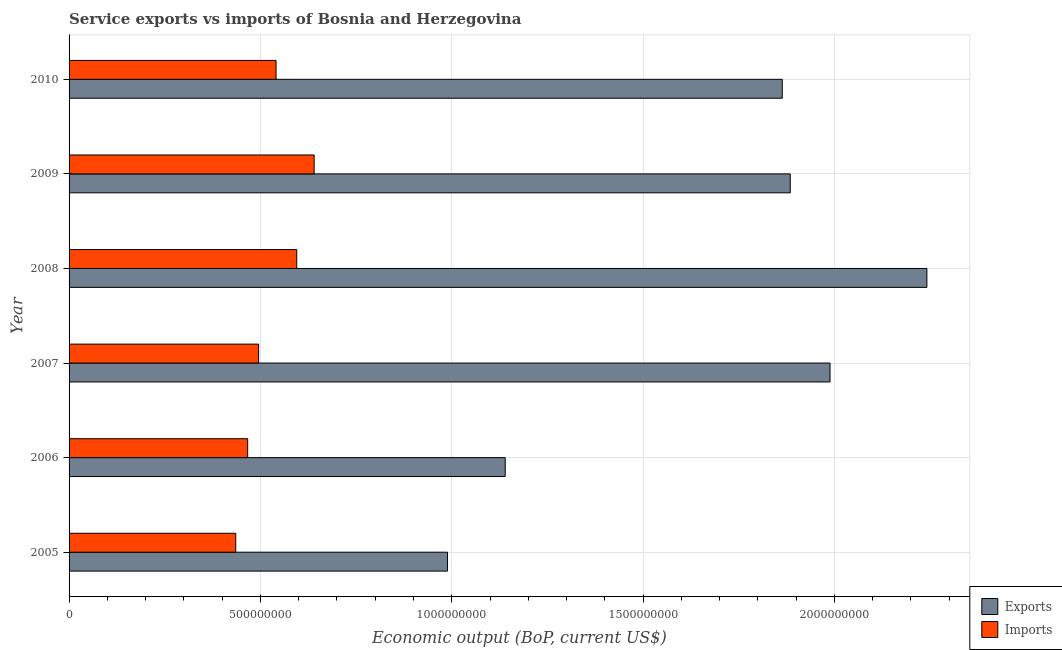How many groups of bars are there?
Offer a very short reply. 6. Are the number of bars on each tick of the Y-axis equal?
Provide a succinct answer. Yes. In how many cases, is the number of bars for a given year not equal to the number of legend labels?
Offer a terse response. 0. What is the amount of service exports in 2006?
Keep it short and to the point. 1.14e+09. Across all years, what is the maximum amount of service imports?
Provide a succinct answer. 6.40e+08. Across all years, what is the minimum amount of service imports?
Your answer should be compact. 4.36e+08. In which year was the amount of service imports minimum?
Provide a short and direct response. 2005. What is the total amount of service exports in the graph?
Offer a very short reply. 1.01e+1. What is the difference between the amount of service imports in 2006 and that in 2008?
Give a very brief answer. -1.28e+08. What is the difference between the amount of service exports in 2009 and the amount of service imports in 2010?
Your answer should be very brief. 1.34e+09. What is the average amount of service exports per year?
Your answer should be very brief. 1.68e+09. In the year 2009, what is the difference between the amount of service exports and amount of service imports?
Offer a terse response. 1.24e+09. In how many years, is the amount of service imports greater than 1000000000 US$?
Your answer should be compact. 0. What is the ratio of the amount of service imports in 2009 to that in 2010?
Your answer should be very brief. 1.18. What is the difference between the highest and the second highest amount of service exports?
Your answer should be compact. 2.53e+08. What is the difference between the highest and the lowest amount of service exports?
Provide a succinct answer. 1.25e+09. In how many years, is the amount of service imports greater than the average amount of service imports taken over all years?
Make the answer very short. 3. Is the sum of the amount of service exports in 2006 and 2010 greater than the maximum amount of service imports across all years?
Your answer should be very brief. Yes. What does the 1st bar from the top in 2006 represents?
Provide a short and direct response. Imports. What does the 2nd bar from the bottom in 2008 represents?
Ensure brevity in your answer.  Imports. Are all the bars in the graph horizontal?
Your answer should be very brief. Yes. How many years are there in the graph?
Give a very brief answer. 6. What is the difference between two consecutive major ticks on the X-axis?
Your answer should be compact. 5.00e+08. Are the values on the major ticks of X-axis written in scientific E-notation?
Ensure brevity in your answer.  No. Where does the legend appear in the graph?
Give a very brief answer. Bottom right. What is the title of the graph?
Give a very brief answer. Service exports vs imports of Bosnia and Herzegovina. What is the label or title of the X-axis?
Your response must be concise. Economic output (BoP, current US$). What is the label or title of the Y-axis?
Your response must be concise. Year. What is the Economic output (BoP, current US$) of Exports in 2005?
Your response must be concise. 9.89e+08. What is the Economic output (BoP, current US$) of Imports in 2005?
Keep it short and to the point. 4.36e+08. What is the Economic output (BoP, current US$) of Exports in 2006?
Your answer should be very brief. 1.14e+09. What is the Economic output (BoP, current US$) of Imports in 2006?
Your response must be concise. 4.67e+08. What is the Economic output (BoP, current US$) in Exports in 2007?
Your answer should be very brief. 1.99e+09. What is the Economic output (BoP, current US$) of Imports in 2007?
Offer a terse response. 4.95e+08. What is the Economic output (BoP, current US$) in Exports in 2008?
Make the answer very short. 2.24e+09. What is the Economic output (BoP, current US$) in Imports in 2008?
Make the answer very short. 5.95e+08. What is the Economic output (BoP, current US$) of Exports in 2009?
Keep it short and to the point. 1.88e+09. What is the Economic output (BoP, current US$) of Imports in 2009?
Give a very brief answer. 6.40e+08. What is the Economic output (BoP, current US$) of Exports in 2010?
Make the answer very short. 1.86e+09. What is the Economic output (BoP, current US$) of Imports in 2010?
Your answer should be compact. 5.41e+08. Across all years, what is the maximum Economic output (BoP, current US$) of Exports?
Your response must be concise. 2.24e+09. Across all years, what is the maximum Economic output (BoP, current US$) of Imports?
Keep it short and to the point. 6.40e+08. Across all years, what is the minimum Economic output (BoP, current US$) of Exports?
Your response must be concise. 9.89e+08. Across all years, what is the minimum Economic output (BoP, current US$) of Imports?
Your answer should be compact. 4.36e+08. What is the total Economic output (BoP, current US$) in Exports in the graph?
Your response must be concise. 1.01e+1. What is the total Economic output (BoP, current US$) of Imports in the graph?
Your response must be concise. 3.17e+09. What is the difference between the Economic output (BoP, current US$) in Exports in 2005 and that in 2006?
Give a very brief answer. -1.51e+08. What is the difference between the Economic output (BoP, current US$) of Imports in 2005 and that in 2006?
Your answer should be very brief. -3.12e+07. What is the difference between the Economic output (BoP, current US$) of Exports in 2005 and that in 2007?
Your answer should be compact. -1.00e+09. What is the difference between the Economic output (BoP, current US$) in Imports in 2005 and that in 2007?
Ensure brevity in your answer.  -5.97e+07. What is the difference between the Economic output (BoP, current US$) in Exports in 2005 and that in 2008?
Offer a terse response. -1.25e+09. What is the difference between the Economic output (BoP, current US$) in Imports in 2005 and that in 2008?
Offer a very short reply. -1.59e+08. What is the difference between the Economic output (BoP, current US$) of Exports in 2005 and that in 2009?
Offer a terse response. -8.96e+08. What is the difference between the Economic output (BoP, current US$) of Imports in 2005 and that in 2009?
Offer a terse response. -2.05e+08. What is the difference between the Economic output (BoP, current US$) in Exports in 2005 and that in 2010?
Offer a very short reply. -8.75e+08. What is the difference between the Economic output (BoP, current US$) in Imports in 2005 and that in 2010?
Ensure brevity in your answer.  -1.05e+08. What is the difference between the Economic output (BoP, current US$) of Exports in 2006 and that in 2007?
Your answer should be compact. -8.49e+08. What is the difference between the Economic output (BoP, current US$) in Imports in 2006 and that in 2007?
Provide a short and direct response. -2.86e+07. What is the difference between the Economic output (BoP, current US$) of Exports in 2006 and that in 2008?
Provide a succinct answer. -1.10e+09. What is the difference between the Economic output (BoP, current US$) in Imports in 2006 and that in 2008?
Your response must be concise. -1.28e+08. What is the difference between the Economic output (BoP, current US$) of Exports in 2006 and that in 2009?
Offer a very short reply. -7.45e+08. What is the difference between the Economic output (BoP, current US$) in Imports in 2006 and that in 2009?
Offer a very short reply. -1.74e+08. What is the difference between the Economic output (BoP, current US$) of Exports in 2006 and that in 2010?
Give a very brief answer. -7.24e+08. What is the difference between the Economic output (BoP, current US$) of Imports in 2006 and that in 2010?
Make the answer very short. -7.42e+07. What is the difference between the Economic output (BoP, current US$) in Exports in 2007 and that in 2008?
Your answer should be compact. -2.53e+08. What is the difference between the Economic output (BoP, current US$) in Imports in 2007 and that in 2008?
Provide a succinct answer. -9.97e+07. What is the difference between the Economic output (BoP, current US$) in Exports in 2007 and that in 2009?
Offer a very short reply. 1.04e+08. What is the difference between the Economic output (BoP, current US$) in Imports in 2007 and that in 2009?
Offer a terse response. -1.45e+08. What is the difference between the Economic output (BoP, current US$) of Exports in 2007 and that in 2010?
Make the answer very short. 1.25e+08. What is the difference between the Economic output (BoP, current US$) in Imports in 2007 and that in 2010?
Your answer should be compact. -4.56e+07. What is the difference between the Economic output (BoP, current US$) in Exports in 2008 and that in 2009?
Provide a succinct answer. 3.57e+08. What is the difference between the Economic output (BoP, current US$) of Imports in 2008 and that in 2009?
Your answer should be very brief. -4.55e+07. What is the difference between the Economic output (BoP, current US$) in Exports in 2008 and that in 2010?
Offer a terse response. 3.78e+08. What is the difference between the Economic output (BoP, current US$) of Imports in 2008 and that in 2010?
Keep it short and to the point. 5.40e+07. What is the difference between the Economic output (BoP, current US$) in Exports in 2009 and that in 2010?
Your answer should be very brief. 2.09e+07. What is the difference between the Economic output (BoP, current US$) of Imports in 2009 and that in 2010?
Offer a very short reply. 9.95e+07. What is the difference between the Economic output (BoP, current US$) of Exports in 2005 and the Economic output (BoP, current US$) of Imports in 2006?
Make the answer very short. 5.22e+08. What is the difference between the Economic output (BoP, current US$) of Exports in 2005 and the Economic output (BoP, current US$) of Imports in 2007?
Offer a terse response. 4.94e+08. What is the difference between the Economic output (BoP, current US$) in Exports in 2005 and the Economic output (BoP, current US$) in Imports in 2008?
Offer a very short reply. 3.94e+08. What is the difference between the Economic output (BoP, current US$) in Exports in 2005 and the Economic output (BoP, current US$) in Imports in 2009?
Offer a terse response. 3.49e+08. What is the difference between the Economic output (BoP, current US$) in Exports in 2005 and the Economic output (BoP, current US$) in Imports in 2010?
Provide a short and direct response. 4.48e+08. What is the difference between the Economic output (BoP, current US$) in Exports in 2006 and the Economic output (BoP, current US$) in Imports in 2007?
Offer a terse response. 6.44e+08. What is the difference between the Economic output (BoP, current US$) of Exports in 2006 and the Economic output (BoP, current US$) of Imports in 2008?
Your answer should be compact. 5.45e+08. What is the difference between the Economic output (BoP, current US$) of Exports in 2006 and the Economic output (BoP, current US$) of Imports in 2009?
Give a very brief answer. 4.99e+08. What is the difference between the Economic output (BoP, current US$) in Exports in 2006 and the Economic output (BoP, current US$) in Imports in 2010?
Ensure brevity in your answer.  5.99e+08. What is the difference between the Economic output (BoP, current US$) in Exports in 2007 and the Economic output (BoP, current US$) in Imports in 2008?
Your answer should be compact. 1.39e+09. What is the difference between the Economic output (BoP, current US$) in Exports in 2007 and the Economic output (BoP, current US$) in Imports in 2009?
Your answer should be very brief. 1.35e+09. What is the difference between the Economic output (BoP, current US$) in Exports in 2007 and the Economic output (BoP, current US$) in Imports in 2010?
Provide a short and direct response. 1.45e+09. What is the difference between the Economic output (BoP, current US$) of Exports in 2008 and the Economic output (BoP, current US$) of Imports in 2009?
Provide a succinct answer. 1.60e+09. What is the difference between the Economic output (BoP, current US$) in Exports in 2008 and the Economic output (BoP, current US$) in Imports in 2010?
Offer a terse response. 1.70e+09. What is the difference between the Economic output (BoP, current US$) in Exports in 2009 and the Economic output (BoP, current US$) in Imports in 2010?
Your answer should be compact. 1.34e+09. What is the average Economic output (BoP, current US$) in Exports per year?
Make the answer very short. 1.68e+09. What is the average Economic output (BoP, current US$) in Imports per year?
Keep it short and to the point. 5.29e+08. In the year 2005, what is the difference between the Economic output (BoP, current US$) of Exports and Economic output (BoP, current US$) of Imports?
Provide a succinct answer. 5.53e+08. In the year 2006, what is the difference between the Economic output (BoP, current US$) of Exports and Economic output (BoP, current US$) of Imports?
Ensure brevity in your answer.  6.73e+08. In the year 2007, what is the difference between the Economic output (BoP, current US$) in Exports and Economic output (BoP, current US$) in Imports?
Offer a terse response. 1.49e+09. In the year 2008, what is the difference between the Economic output (BoP, current US$) in Exports and Economic output (BoP, current US$) in Imports?
Offer a terse response. 1.65e+09. In the year 2009, what is the difference between the Economic output (BoP, current US$) of Exports and Economic output (BoP, current US$) of Imports?
Make the answer very short. 1.24e+09. In the year 2010, what is the difference between the Economic output (BoP, current US$) in Exports and Economic output (BoP, current US$) in Imports?
Your response must be concise. 1.32e+09. What is the ratio of the Economic output (BoP, current US$) in Exports in 2005 to that in 2006?
Make the answer very short. 0.87. What is the ratio of the Economic output (BoP, current US$) in Imports in 2005 to that in 2006?
Make the answer very short. 0.93. What is the ratio of the Economic output (BoP, current US$) in Exports in 2005 to that in 2007?
Your answer should be compact. 0.5. What is the ratio of the Economic output (BoP, current US$) of Imports in 2005 to that in 2007?
Make the answer very short. 0.88. What is the ratio of the Economic output (BoP, current US$) of Exports in 2005 to that in 2008?
Offer a terse response. 0.44. What is the ratio of the Economic output (BoP, current US$) of Imports in 2005 to that in 2008?
Your response must be concise. 0.73. What is the ratio of the Economic output (BoP, current US$) of Exports in 2005 to that in 2009?
Your response must be concise. 0.52. What is the ratio of the Economic output (BoP, current US$) of Imports in 2005 to that in 2009?
Your answer should be compact. 0.68. What is the ratio of the Economic output (BoP, current US$) in Exports in 2005 to that in 2010?
Give a very brief answer. 0.53. What is the ratio of the Economic output (BoP, current US$) of Imports in 2005 to that in 2010?
Your answer should be compact. 0.81. What is the ratio of the Economic output (BoP, current US$) in Exports in 2006 to that in 2007?
Keep it short and to the point. 0.57. What is the ratio of the Economic output (BoP, current US$) of Imports in 2006 to that in 2007?
Provide a short and direct response. 0.94. What is the ratio of the Economic output (BoP, current US$) in Exports in 2006 to that in 2008?
Ensure brevity in your answer.  0.51. What is the ratio of the Economic output (BoP, current US$) of Imports in 2006 to that in 2008?
Your response must be concise. 0.78. What is the ratio of the Economic output (BoP, current US$) of Exports in 2006 to that in 2009?
Ensure brevity in your answer.  0.6. What is the ratio of the Economic output (BoP, current US$) in Imports in 2006 to that in 2009?
Your answer should be very brief. 0.73. What is the ratio of the Economic output (BoP, current US$) in Exports in 2006 to that in 2010?
Ensure brevity in your answer.  0.61. What is the ratio of the Economic output (BoP, current US$) of Imports in 2006 to that in 2010?
Your answer should be very brief. 0.86. What is the ratio of the Economic output (BoP, current US$) in Exports in 2007 to that in 2008?
Ensure brevity in your answer.  0.89. What is the ratio of the Economic output (BoP, current US$) in Imports in 2007 to that in 2008?
Make the answer very short. 0.83. What is the ratio of the Economic output (BoP, current US$) of Exports in 2007 to that in 2009?
Make the answer very short. 1.06. What is the ratio of the Economic output (BoP, current US$) in Imports in 2007 to that in 2009?
Ensure brevity in your answer.  0.77. What is the ratio of the Economic output (BoP, current US$) of Exports in 2007 to that in 2010?
Offer a terse response. 1.07. What is the ratio of the Economic output (BoP, current US$) in Imports in 2007 to that in 2010?
Give a very brief answer. 0.92. What is the ratio of the Economic output (BoP, current US$) of Exports in 2008 to that in 2009?
Ensure brevity in your answer.  1.19. What is the ratio of the Economic output (BoP, current US$) of Imports in 2008 to that in 2009?
Your answer should be compact. 0.93. What is the ratio of the Economic output (BoP, current US$) of Exports in 2008 to that in 2010?
Ensure brevity in your answer.  1.2. What is the ratio of the Economic output (BoP, current US$) of Imports in 2008 to that in 2010?
Keep it short and to the point. 1.1. What is the ratio of the Economic output (BoP, current US$) in Exports in 2009 to that in 2010?
Give a very brief answer. 1.01. What is the ratio of the Economic output (BoP, current US$) in Imports in 2009 to that in 2010?
Your answer should be very brief. 1.18. What is the difference between the highest and the second highest Economic output (BoP, current US$) in Exports?
Ensure brevity in your answer.  2.53e+08. What is the difference between the highest and the second highest Economic output (BoP, current US$) in Imports?
Keep it short and to the point. 4.55e+07. What is the difference between the highest and the lowest Economic output (BoP, current US$) in Exports?
Keep it short and to the point. 1.25e+09. What is the difference between the highest and the lowest Economic output (BoP, current US$) of Imports?
Offer a very short reply. 2.05e+08. 